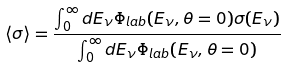<formula> <loc_0><loc_0><loc_500><loc_500>\langle \sigma \rangle = \frac { \int ^ { \infty } _ { 0 } d E _ { \nu } \Phi _ { l a b } ( E _ { \nu } , \theta = 0 ) \sigma ( E _ { \nu } ) } { \int ^ { \infty } _ { 0 } d E _ { \nu } \Phi _ { l a b } ( E _ { \nu } , \theta = 0 ) }</formula> 